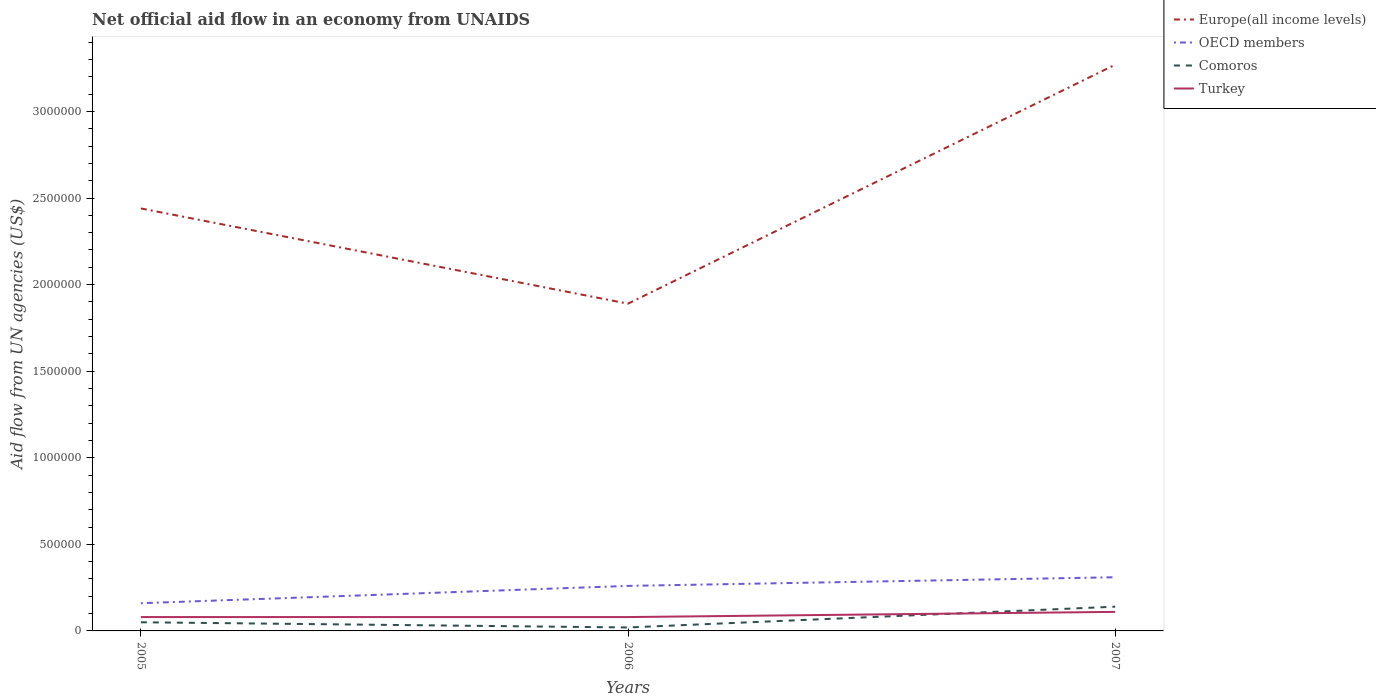How many different coloured lines are there?
Provide a short and direct response. 4. Does the line corresponding to OECD members intersect with the line corresponding to Europe(all income levels)?
Your answer should be compact. No. Is the number of lines equal to the number of legend labels?
Give a very brief answer. Yes. Across all years, what is the maximum net official aid flow in OECD members?
Give a very brief answer. 1.60e+05. What is the total net official aid flow in OECD members in the graph?
Your answer should be compact. -1.50e+05. What is the difference between the highest and the second highest net official aid flow in Turkey?
Your response must be concise. 3.00e+04. What is the difference between two consecutive major ticks on the Y-axis?
Provide a succinct answer. 5.00e+05. Are the values on the major ticks of Y-axis written in scientific E-notation?
Make the answer very short. No. Does the graph contain any zero values?
Provide a succinct answer. No. Does the graph contain grids?
Offer a very short reply. No. How many legend labels are there?
Give a very brief answer. 4. How are the legend labels stacked?
Offer a terse response. Vertical. What is the title of the graph?
Keep it short and to the point. Net official aid flow in an economy from UNAIDS. Does "St. Kitts and Nevis" appear as one of the legend labels in the graph?
Offer a very short reply. No. What is the label or title of the X-axis?
Your response must be concise. Years. What is the label or title of the Y-axis?
Provide a short and direct response. Aid flow from UN agencies (US$). What is the Aid flow from UN agencies (US$) in Europe(all income levels) in 2005?
Provide a succinct answer. 2.44e+06. What is the Aid flow from UN agencies (US$) of OECD members in 2005?
Ensure brevity in your answer.  1.60e+05. What is the Aid flow from UN agencies (US$) in Comoros in 2005?
Keep it short and to the point. 5.00e+04. What is the Aid flow from UN agencies (US$) in Turkey in 2005?
Offer a very short reply. 8.00e+04. What is the Aid flow from UN agencies (US$) in Europe(all income levels) in 2006?
Offer a terse response. 1.89e+06. What is the Aid flow from UN agencies (US$) in OECD members in 2006?
Provide a succinct answer. 2.60e+05. What is the Aid flow from UN agencies (US$) in Turkey in 2006?
Offer a very short reply. 8.00e+04. What is the Aid flow from UN agencies (US$) in Europe(all income levels) in 2007?
Keep it short and to the point. 3.27e+06. What is the Aid flow from UN agencies (US$) in OECD members in 2007?
Your answer should be very brief. 3.10e+05. Across all years, what is the maximum Aid flow from UN agencies (US$) of Europe(all income levels)?
Keep it short and to the point. 3.27e+06. Across all years, what is the maximum Aid flow from UN agencies (US$) of Comoros?
Provide a short and direct response. 1.40e+05. Across all years, what is the maximum Aid flow from UN agencies (US$) in Turkey?
Keep it short and to the point. 1.10e+05. Across all years, what is the minimum Aid flow from UN agencies (US$) of Europe(all income levels)?
Your response must be concise. 1.89e+06. Across all years, what is the minimum Aid flow from UN agencies (US$) in Comoros?
Give a very brief answer. 2.00e+04. Across all years, what is the minimum Aid flow from UN agencies (US$) of Turkey?
Provide a succinct answer. 8.00e+04. What is the total Aid flow from UN agencies (US$) in Europe(all income levels) in the graph?
Offer a terse response. 7.60e+06. What is the total Aid flow from UN agencies (US$) of OECD members in the graph?
Your answer should be very brief. 7.30e+05. What is the total Aid flow from UN agencies (US$) in Comoros in the graph?
Your answer should be compact. 2.10e+05. What is the difference between the Aid flow from UN agencies (US$) in OECD members in 2005 and that in 2006?
Offer a very short reply. -1.00e+05. What is the difference between the Aid flow from UN agencies (US$) of Comoros in 2005 and that in 2006?
Keep it short and to the point. 3.00e+04. What is the difference between the Aid flow from UN agencies (US$) of Europe(all income levels) in 2005 and that in 2007?
Ensure brevity in your answer.  -8.30e+05. What is the difference between the Aid flow from UN agencies (US$) of Comoros in 2005 and that in 2007?
Your response must be concise. -9.00e+04. What is the difference between the Aid flow from UN agencies (US$) in Europe(all income levels) in 2006 and that in 2007?
Offer a very short reply. -1.38e+06. What is the difference between the Aid flow from UN agencies (US$) in Turkey in 2006 and that in 2007?
Your answer should be very brief. -3.00e+04. What is the difference between the Aid flow from UN agencies (US$) of Europe(all income levels) in 2005 and the Aid flow from UN agencies (US$) of OECD members in 2006?
Keep it short and to the point. 2.18e+06. What is the difference between the Aid flow from UN agencies (US$) of Europe(all income levels) in 2005 and the Aid flow from UN agencies (US$) of Comoros in 2006?
Offer a terse response. 2.42e+06. What is the difference between the Aid flow from UN agencies (US$) in Europe(all income levels) in 2005 and the Aid flow from UN agencies (US$) in Turkey in 2006?
Offer a very short reply. 2.36e+06. What is the difference between the Aid flow from UN agencies (US$) in OECD members in 2005 and the Aid flow from UN agencies (US$) in Turkey in 2006?
Make the answer very short. 8.00e+04. What is the difference between the Aid flow from UN agencies (US$) in Comoros in 2005 and the Aid flow from UN agencies (US$) in Turkey in 2006?
Offer a terse response. -3.00e+04. What is the difference between the Aid flow from UN agencies (US$) in Europe(all income levels) in 2005 and the Aid flow from UN agencies (US$) in OECD members in 2007?
Give a very brief answer. 2.13e+06. What is the difference between the Aid flow from UN agencies (US$) in Europe(all income levels) in 2005 and the Aid flow from UN agencies (US$) in Comoros in 2007?
Keep it short and to the point. 2.30e+06. What is the difference between the Aid flow from UN agencies (US$) of Europe(all income levels) in 2005 and the Aid flow from UN agencies (US$) of Turkey in 2007?
Provide a short and direct response. 2.33e+06. What is the difference between the Aid flow from UN agencies (US$) of Europe(all income levels) in 2006 and the Aid flow from UN agencies (US$) of OECD members in 2007?
Make the answer very short. 1.58e+06. What is the difference between the Aid flow from UN agencies (US$) in Europe(all income levels) in 2006 and the Aid flow from UN agencies (US$) in Comoros in 2007?
Offer a very short reply. 1.75e+06. What is the difference between the Aid flow from UN agencies (US$) in Europe(all income levels) in 2006 and the Aid flow from UN agencies (US$) in Turkey in 2007?
Give a very brief answer. 1.78e+06. What is the difference between the Aid flow from UN agencies (US$) of OECD members in 2006 and the Aid flow from UN agencies (US$) of Comoros in 2007?
Your answer should be very brief. 1.20e+05. What is the difference between the Aid flow from UN agencies (US$) of Comoros in 2006 and the Aid flow from UN agencies (US$) of Turkey in 2007?
Ensure brevity in your answer.  -9.00e+04. What is the average Aid flow from UN agencies (US$) of Europe(all income levels) per year?
Your response must be concise. 2.53e+06. What is the average Aid flow from UN agencies (US$) of OECD members per year?
Your answer should be very brief. 2.43e+05. What is the average Aid flow from UN agencies (US$) in Comoros per year?
Provide a short and direct response. 7.00e+04. What is the average Aid flow from UN agencies (US$) of Turkey per year?
Offer a terse response. 9.00e+04. In the year 2005, what is the difference between the Aid flow from UN agencies (US$) in Europe(all income levels) and Aid flow from UN agencies (US$) in OECD members?
Provide a short and direct response. 2.28e+06. In the year 2005, what is the difference between the Aid flow from UN agencies (US$) of Europe(all income levels) and Aid flow from UN agencies (US$) of Comoros?
Give a very brief answer. 2.39e+06. In the year 2005, what is the difference between the Aid flow from UN agencies (US$) of Europe(all income levels) and Aid flow from UN agencies (US$) of Turkey?
Give a very brief answer. 2.36e+06. In the year 2005, what is the difference between the Aid flow from UN agencies (US$) of OECD members and Aid flow from UN agencies (US$) of Turkey?
Ensure brevity in your answer.  8.00e+04. In the year 2006, what is the difference between the Aid flow from UN agencies (US$) of Europe(all income levels) and Aid flow from UN agencies (US$) of OECD members?
Ensure brevity in your answer.  1.63e+06. In the year 2006, what is the difference between the Aid flow from UN agencies (US$) of Europe(all income levels) and Aid flow from UN agencies (US$) of Comoros?
Your answer should be very brief. 1.87e+06. In the year 2006, what is the difference between the Aid flow from UN agencies (US$) of Europe(all income levels) and Aid flow from UN agencies (US$) of Turkey?
Provide a succinct answer. 1.81e+06. In the year 2006, what is the difference between the Aid flow from UN agencies (US$) in OECD members and Aid flow from UN agencies (US$) in Turkey?
Your answer should be compact. 1.80e+05. In the year 2007, what is the difference between the Aid flow from UN agencies (US$) in Europe(all income levels) and Aid flow from UN agencies (US$) in OECD members?
Provide a succinct answer. 2.96e+06. In the year 2007, what is the difference between the Aid flow from UN agencies (US$) of Europe(all income levels) and Aid flow from UN agencies (US$) of Comoros?
Offer a terse response. 3.13e+06. In the year 2007, what is the difference between the Aid flow from UN agencies (US$) of Europe(all income levels) and Aid flow from UN agencies (US$) of Turkey?
Offer a terse response. 3.16e+06. In the year 2007, what is the difference between the Aid flow from UN agencies (US$) of OECD members and Aid flow from UN agencies (US$) of Comoros?
Offer a terse response. 1.70e+05. In the year 2007, what is the difference between the Aid flow from UN agencies (US$) in Comoros and Aid flow from UN agencies (US$) in Turkey?
Your response must be concise. 3.00e+04. What is the ratio of the Aid flow from UN agencies (US$) in Europe(all income levels) in 2005 to that in 2006?
Offer a very short reply. 1.29. What is the ratio of the Aid flow from UN agencies (US$) of OECD members in 2005 to that in 2006?
Your answer should be compact. 0.62. What is the ratio of the Aid flow from UN agencies (US$) in Comoros in 2005 to that in 2006?
Give a very brief answer. 2.5. What is the ratio of the Aid flow from UN agencies (US$) in Turkey in 2005 to that in 2006?
Offer a terse response. 1. What is the ratio of the Aid flow from UN agencies (US$) of Europe(all income levels) in 2005 to that in 2007?
Offer a very short reply. 0.75. What is the ratio of the Aid flow from UN agencies (US$) in OECD members in 2005 to that in 2007?
Keep it short and to the point. 0.52. What is the ratio of the Aid flow from UN agencies (US$) in Comoros in 2005 to that in 2007?
Provide a short and direct response. 0.36. What is the ratio of the Aid flow from UN agencies (US$) in Turkey in 2005 to that in 2007?
Keep it short and to the point. 0.73. What is the ratio of the Aid flow from UN agencies (US$) of Europe(all income levels) in 2006 to that in 2007?
Your answer should be compact. 0.58. What is the ratio of the Aid flow from UN agencies (US$) of OECD members in 2006 to that in 2007?
Make the answer very short. 0.84. What is the ratio of the Aid flow from UN agencies (US$) in Comoros in 2006 to that in 2007?
Offer a very short reply. 0.14. What is the ratio of the Aid flow from UN agencies (US$) of Turkey in 2006 to that in 2007?
Your answer should be very brief. 0.73. What is the difference between the highest and the second highest Aid flow from UN agencies (US$) in Europe(all income levels)?
Make the answer very short. 8.30e+05. What is the difference between the highest and the second highest Aid flow from UN agencies (US$) of Comoros?
Provide a short and direct response. 9.00e+04. What is the difference between the highest and the lowest Aid flow from UN agencies (US$) of Europe(all income levels)?
Give a very brief answer. 1.38e+06. What is the difference between the highest and the lowest Aid flow from UN agencies (US$) in OECD members?
Your response must be concise. 1.50e+05. What is the difference between the highest and the lowest Aid flow from UN agencies (US$) in Turkey?
Your answer should be compact. 3.00e+04. 